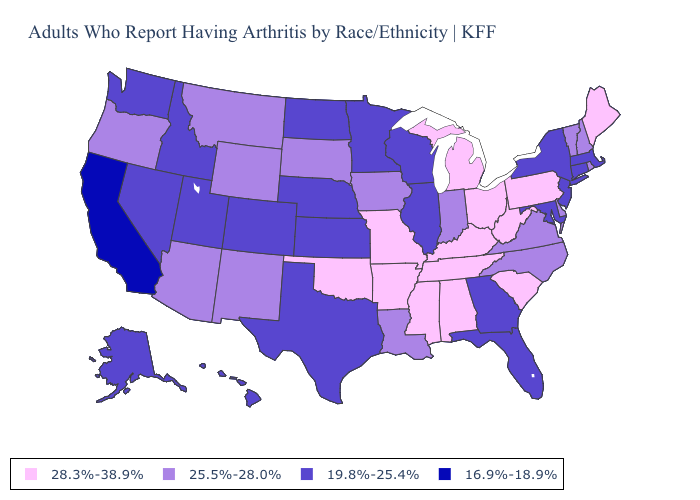What is the value of Kentucky?
Be succinct. 28.3%-38.9%. Name the states that have a value in the range 25.5%-28.0%?
Answer briefly. Arizona, Delaware, Indiana, Iowa, Louisiana, Montana, New Hampshire, New Mexico, North Carolina, Oregon, Rhode Island, South Dakota, Vermont, Virginia, Wyoming. Does the first symbol in the legend represent the smallest category?
Concise answer only. No. Is the legend a continuous bar?
Short answer required. No. Does Nebraska have the highest value in the MidWest?
Concise answer only. No. Name the states that have a value in the range 16.9%-18.9%?
Write a very short answer. California. Does Illinois have the lowest value in the MidWest?
Concise answer only. Yes. What is the lowest value in the South?
Answer briefly. 19.8%-25.4%. Name the states that have a value in the range 28.3%-38.9%?
Be succinct. Alabama, Arkansas, Kentucky, Maine, Michigan, Mississippi, Missouri, Ohio, Oklahoma, Pennsylvania, South Carolina, Tennessee, West Virginia. Among the states that border New Jersey , which have the highest value?
Concise answer only. Pennsylvania. What is the value of Kentucky?
Keep it brief. 28.3%-38.9%. What is the value of Rhode Island?
Concise answer only. 25.5%-28.0%. Name the states that have a value in the range 25.5%-28.0%?
Answer briefly. Arizona, Delaware, Indiana, Iowa, Louisiana, Montana, New Hampshire, New Mexico, North Carolina, Oregon, Rhode Island, South Dakota, Vermont, Virginia, Wyoming. Is the legend a continuous bar?
Be succinct. No. What is the highest value in the USA?
Keep it brief. 28.3%-38.9%. 